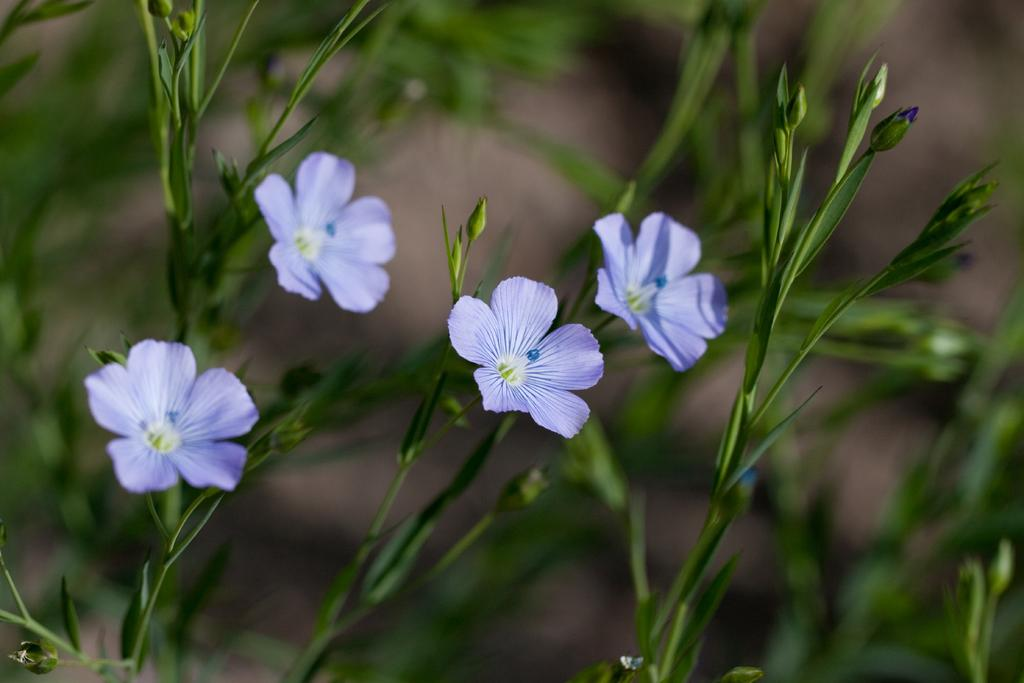What type of living organisms are present in the image? There are plants in the image. What specific feature can be observed on the plants? The plants have flowers. Are there any stages of growth visible on the flowers? Yes, the flowers have flower buds. What color are the flowers in the image? The flowers are light violet in color. How is the distribution of roses controlled in the image? There are no roses present in the image, so the distribution of roses cannot be controlled or observed. 